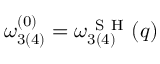Convert formula to latex. <formula><loc_0><loc_0><loc_500><loc_500>\omega _ { 3 ( 4 ) } ^ { ( 0 ) } = \omega _ { 3 ( 4 ) } ^ { S H } ( q )</formula> 